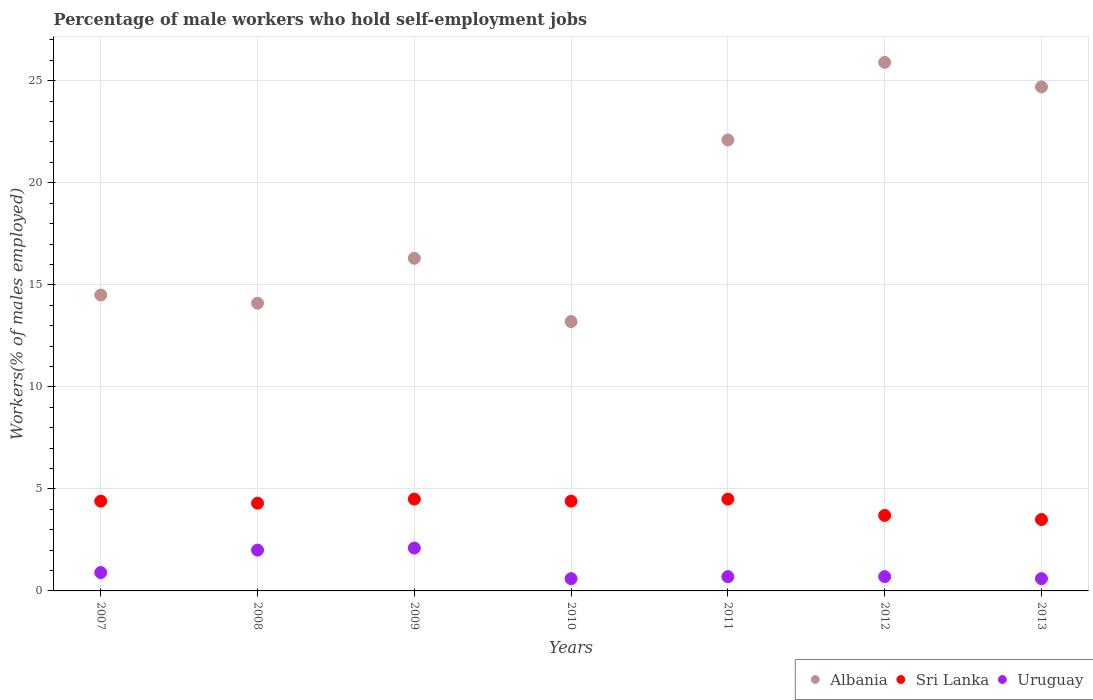How many different coloured dotlines are there?
Make the answer very short. 3. Is the number of dotlines equal to the number of legend labels?
Offer a very short reply. Yes. Across all years, what is the maximum percentage of self-employed male workers in Albania?
Your answer should be very brief. 25.9. Across all years, what is the minimum percentage of self-employed male workers in Sri Lanka?
Provide a succinct answer. 3.5. In which year was the percentage of self-employed male workers in Uruguay maximum?
Make the answer very short. 2009. In which year was the percentage of self-employed male workers in Uruguay minimum?
Your response must be concise. 2010. What is the total percentage of self-employed male workers in Sri Lanka in the graph?
Your answer should be compact. 29.3. What is the difference between the percentage of self-employed male workers in Albania in 2008 and that in 2010?
Your response must be concise. 0.9. What is the difference between the percentage of self-employed male workers in Albania in 2007 and the percentage of self-employed male workers in Sri Lanka in 2012?
Keep it short and to the point. 10.8. What is the average percentage of self-employed male workers in Sri Lanka per year?
Offer a terse response. 4.19. In the year 2010, what is the difference between the percentage of self-employed male workers in Sri Lanka and percentage of self-employed male workers in Uruguay?
Give a very brief answer. 3.8. What is the ratio of the percentage of self-employed male workers in Albania in 2011 to that in 2013?
Offer a very short reply. 0.89. Is the percentage of self-employed male workers in Sri Lanka in 2011 less than that in 2013?
Make the answer very short. No. Is the difference between the percentage of self-employed male workers in Sri Lanka in 2008 and 2012 greater than the difference between the percentage of self-employed male workers in Uruguay in 2008 and 2012?
Ensure brevity in your answer.  No. What is the difference between the highest and the lowest percentage of self-employed male workers in Sri Lanka?
Offer a terse response. 1. In how many years, is the percentage of self-employed male workers in Albania greater than the average percentage of self-employed male workers in Albania taken over all years?
Give a very brief answer. 3. Is the sum of the percentage of self-employed male workers in Albania in 2007 and 2012 greater than the maximum percentage of self-employed male workers in Sri Lanka across all years?
Give a very brief answer. Yes. How many dotlines are there?
Ensure brevity in your answer.  3. How many years are there in the graph?
Your answer should be compact. 7. What is the difference between two consecutive major ticks on the Y-axis?
Provide a short and direct response. 5. Does the graph contain grids?
Make the answer very short. Yes. Where does the legend appear in the graph?
Provide a succinct answer. Bottom right. How are the legend labels stacked?
Your response must be concise. Horizontal. What is the title of the graph?
Your response must be concise. Percentage of male workers who hold self-employment jobs. What is the label or title of the X-axis?
Your response must be concise. Years. What is the label or title of the Y-axis?
Your answer should be very brief. Workers(% of males employed). What is the Workers(% of males employed) in Albania in 2007?
Your answer should be very brief. 14.5. What is the Workers(% of males employed) of Sri Lanka in 2007?
Your response must be concise. 4.4. What is the Workers(% of males employed) of Uruguay in 2007?
Provide a succinct answer. 0.9. What is the Workers(% of males employed) in Albania in 2008?
Provide a succinct answer. 14.1. What is the Workers(% of males employed) in Sri Lanka in 2008?
Give a very brief answer. 4.3. What is the Workers(% of males employed) in Albania in 2009?
Your answer should be compact. 16.3. What is the Workers(% of males employed) in Uruguay in 2009?
Your answer should be very brief. 2.1. What is the Workers(% of males employed) of Albania in 2010?
Make the answer very short. 13.2. What is the Workers(% of males employed) in Sri Lanka in 2010?
Offer a terse response. 4.4. What is the Workers(% of males employed) of Uruguay in 2010?
Keep it short and to the point. 0.6. What is the Workers(% of males employed) in Albania in 2011?
Give a very brief answer. 22.1. What is the Workers(% of males employed) in Sri Lanka in 2011?
Your response must be concise. 4.5. What is the Workers(% of males employed) of Uruguay in 2011?
Keep it short and to the point. 0.7. What is the Workers(% of males employed) of Albania in 2012?
Offer a terse response. 25.9. What is the Workers(% of males employed) in Sri Lanka in 2012?
Give a very brief answer. 3.7. What is the Workers(% of males employed) in Uruguay in 2012?
Provide a short and direct response. 0.7. What is the Workers(% of males employed) in Albania in 2013?
Provide a succinct answer. 24.7. What is the Workers(% of males employed) in Uruguay in 2013?
Keep it short and to the point. 0.6. Across all years, what is the maximum Workers(% of males employed) of Albania?
Provide a succinct answer. 25.9. Across all years, what is the maximum Workers(% of males employed) of Uruguay?
Provide a succinct answer. 2.1. Across all years, what is the minimum Workers(% of males employed) in Albania?
Ensure brevity in your answer.  13.2. Across all years, what is the minimum Workers(% of males employed) in Sri Lanka?
Your answer should be very brief. 3.5. Across all years, what is the minimum Workers(% of males employed) in Uruguay?
Your answer should be very brief. 0.6. What is the total Workers(% of males employed) in Albania in the graph?
Provide a short and direct response. 130.8. What is the total Workers(% of males employed) of Sri Lanka in the graph?
Offer a very short reply. 29.3. What is the total Workers(% of males employed) of Uruguay in the graph?
Your answer should be very brief. 7.6. What is the difference between the Workers(% of males employed) of Albania in 2007 and that in 2008?
Give a very brief answer. 0.4. What is the difference between the Workers(% of males employed) of Uruguay in 2007 and that in 2008?
Ensure brevity in your answer.  -1.1. What is the difference between the Workers(% of males employed) of Sri Lanka in 2007 and that in 2009?
Give a very brief answer. -0.1. What is the difference between the Workers(% of males employed) of Uruguay in 2007 and that in 2009?
Provide a short and direct response. -1.2. What is the difference between the Workers(% of males employed) in Sri Lanka in 2007 and that in 2010?
Your answer should be very brief. 0. What is the difference between the Workers(% of males employed) in Sri Lanka in 2007 and that in 2011?
Give a very brief answer. -0.1. What is the difference between the Workers(% of males employed) in Albania in 2007 and that in 2012?
Provide a succinct answer. -11.4. What is the difference between the Workers(% of males employed) of Sri Lanka in 2007 and that in 2012?
Make the answer very short. 0.7. What is the difference between the Workers(% of males employed) in Albania in 2007 and that in 2013?
Your response must be concise. -10.2. What is the difference between the Workers(% of males employed) in Sri Lanka in 2007 and that in 2013?
Keep it short and to the point. 0.9. What is the difference between the Workers(% of males employed) in Sri Lanka in 2008 and that in 2009?
Provide a short and direct response. -0.2. What is the difference between the Workers(% of males employed) of Albania in 2008 and that in 2010?
Your response must be concise. 0.9. What is the difference between the Workers(% of males employed) of Sri Lanka in 2008 and that in 2010?
Ensure brevity in your answer.  -0.1. What is the difference between the Workers(% of males employed) of Sri Lanka in 2008 and that in 2011?
Provide a short and direct response. -0.2. What is the difference between the Workers(% of males employed) in Sri Lanka in 2008 and that in 2012?
Make the answer very short. 0.6. What is the difference between the Workers(% of males employed) of Uruguay in 2008 and that in 2012?
Your response must be concise. 1.3. What is the difference between the Workers(% of males employed) in Uruguay in 2008 and that in 2013?
Your answer should be compact. 1.4. What is the difference between the Workers(% of males employed) in Sri Lanka in 2009 and that in 2010?
Offer a very short reply. 0.1. What is the difference between the Workers(% of males employed) of Uruguay in 2009 and that in 2010?
Ensure brevity in your answer.  1.5. What is the difference between the Workers(% of males employed) of Uruguay in 2009 and that in 2011?
Provide a short and direct response. 1.4. What is the difference between the Workers(% of males employed) in Albania in 2009 and that in 2012?
Ensure brevity in your answer.  -9.6. What is the difference between the Workers(% of males employed) of Albania in 2009 and that in 2013?
Give a very brief answer. -8.4. What is the difference between the Workers(% of males employed) in Albania in 2010 and that in 2011?
Your response must be concise. -8.9. What is the difference between the Workers(% of males employed) in Sri Lanka in 2010 and that in 2011?
Offer a very short reply. -0.1. What is the difference between the Workers(% of males employed) in Uruguay in 2010 and that in 2011?
Ensure brevity in your answer.  -0.1. What is the difference between the Workers(% of males employed) of Sri Lanka in 2010 and that in 2012?
Provide a short and direct response. 0.7. What is the difference between the Workers(% of males employed) of Uruguay in 2010 and that in 2012?
Your answer should be compact. -0.1. What is the difference between the Workers(% of males employed) in Albania in 2011 and that in 2012?
Give a very brief answer. -3.8. What is the difference between the Workers(% of males employed) of Albania in 2011 and that in 2013?
Your response must be concise. -2.6. What is the difference between the Workers(% of males employed) in Albania in 2012 and that in 2013?
Offer a terse response. 1.2. What is the difference between the Workers(% of males employed) of Uruguay in 2012 and that in 2013?
Make the answer very short. 0.1. What is the difference between the Workers(% of males employed) in Albania in 2007 and the Workers(% of males employed) in Sri Lanka in 2008?
Your answer should be very brief. 10.2. What is the difference between the Workers(% of males employed) of Albania in 2007 and the Workers(% of males employed) of Uruguay in 2008?
Ensure brevity in your answer.  12.5. What is the difference between the Workers(% of males employed) of Albania in 2007 and the Workers(% of males employed) of Sri Lanka in 2009?
Ensure brevity in your answer.  10. What is the difference between the Workers(% of males employed) in Albania in 2007 and the Workers(% of males employed) in Uruguay in 2009?
Your response must be concise. 12.4. What is the difference between the Workers(% of males employed) of Albania in 2007 and the Workers(% of males employed) of Sri Lanka in 2010?
Ensure brevity in your answer.  10.1. What is the difference between the Workers(% of males employed) in Sri Lanka in 2007 and the Workers(% of males employed) in Uruguay in 2011?
Keep it short and to the point. 3.7. What is the difference between the Workers(% of males employed) in Sri Lanka in 2007 and the Workers(% of males employed) in Uruguay in 2012?
Your answer should be compact. 3.7. What is the difference between the Workers(% of males employed) of Albania in 2007 and the Workers(% of males employed) of Sri Lanka in 2013?
Provide a short and direct response. 11. What is the difference between the Workers(% of males employed) of Sri Lanka in 2007 and the Workers(% of males employed) of Uruguay in 2013?
Your answer should be very brief. 3.8. What is the difference between the Workers(% of males employed) of Albania in 2008 and the Workers(% of males employed) of Sri Lanka in 2010?
Give a very brief answer. 9.7. What is the difference between the Workers(% of males employed) in Albania in 2008 and the Workers(% of males employed) in Uruguay in 2011?
Your response must be concise. 13.4. What is the difference between the Workers(% of males employed) of Albania in 2008 and the Workers(% of males employed) of Sri Lanka in 2012?
Your answer should be compact. 10.4. What is the difference between the Workers(% of males employed) of Sri Lanka in 2008 and the Workers(% of males employed) of Uruguay in 2012?
Give a very brief answer. 3.6. What is the difference between the Workers(% of males employed) of Sri Lanka in 2009 and the Workers(% of males employed) of Uruguay in 2010?
Your answer should be very brief. 3.9. What is the difference between the Workers(% of males employed) in Albania in 2009 and the Workers(% of males employed) in Uruguay in 2011?
Provide a succinct answer. 15.6. What is the difference between the Workers(% of males employed) in Sri Lanka in 2009 and the Workers(% of males employed) in Uruguay in 2011?
Keep it short and to the point. 3.8. What is the difference between the Workers(% of males employed) of Albania in 2009 and the Workers(% of males employed) of Sri Lanka in 2012?
Give a very brief answer. 12.6. What is the difference between the Workers(% of males employed) in Albania in 2009 and the Workers(% of males employed) in Uruguay in 2012?
Keep it short and to the point. 15.6. What is the difference between the Workers(% of males employed) in Albania in 2009 and the Workers(% of males employed) in Sri Lanka in 2013?
Ensure brevity in your answer.  12.8. What is the difference between the Workers(% of males employed) in Albania in 2009 and the Workers(% of males employed) in Uruguay in 2013?
Ensure brevity in your answer.  15.7. What is the difference between the Workers(% of males employed) in Sri Lanka in 2010 and the Workers(% of males employed) in Uruguay in 2011?
Provide a succinct answer. 3.7. What is the difference between the Workers(% of males employed) in Albania in 2010 and the Workers(% of males employed) in Uruguay in 2012?
Your response must be concise. 12.5. What is the difference between the Workers(% of males employed) in Sri Lanka in 2010 and the Workers(% of males employed) in Uruguay in 2013?
Keep it short and to the point. 3.8. What is the difference between the Workers(% of males employed) in Albania in 2011 and the Workers(% of males employed) in Sri Lanka in 2012?
Offer a very short reply. 18.4. What is the difference between the Workers(% of males employed) of Albania in 2011 and the Workers(% of males employed) of Uruguay in 2012?
Offer a terse response. 21.4. What is the difference between the Workers(% of males employed) of Albania in 2012 and the Workers(% of males employed) of Sri Lanka in 2013?
Your answer should be compact. 22.4. What is the difference between the Workers(% of males employed) in Albania in 2012 and the Workers(% of males employed) in Uruguay in 2013?
Offer a terse response. 25.3. What is the average Workers(% of males employed) in Albania per year?
Your answer should be very brief. 18.69. What is the average Workers(% of males employed) in Sri Lanka per year?
Offer a very short reply. 4.19. What is the average Workers(% of males employed) in Uruguay per year?
Offer a very short reply. 1.09. In the year 2007, what is the difference between the Workers(% of males employed) in Albania and Workers(% of males employed) in Uruguay?
Keep it short and to the point. 13.6. In the year 2007, what is the difference between the Workers(% of males employed) in Sri Lanka and Workers(% of males employed) in Uruguay?
Give a very brief answer. 3.5. In the year 2010, what is the difference between the Workers(% of males employed) of Sri Lanka and Workers(% of males employed) of Uruguay?
Make the answer very short. 3.8. In the year 2011, what is the difference between the Workers(% of males employed) of Albania and Workers(% of males employed) of Sri Lanka?
Offer a terse response. 17.6. In the year 2011, what is the difference between the Workers(% of males employed) in Albania and Workers(% of males employed) in Uruguay?
Ensure brevity in your answer.  21.4. In the year 2012, what is the difference between the Workers(% of males employed) in Albania and Workers(% of males employed) in Uruguay?
Your answer should be compact. 25.2. In the year 2012, what is the difference between the Workers(% of males employed) in Sri Lanka and Workers(% of males employed) in Uruguay?
Your answer should be very brief. 3. In the year 2013, what is the difference between the Workers(% of males employed) of Albania and Workers(% of males employed) of Sri Lanka?
Ensure brevity in your answer.  21.2. In the year 2013, what is the difference between the Workers(% of males employed) of Albania and Workers(% of males employed) of Uruguay?
Ensure brevity in your answer.  24.1. What is the ratio of the Workers(% of males employed) of Albania in 2007 to that in 2008?
Keep it short and to the point. 1.03. What is the ratio of the Workers(% of males employed) of Sri Lanka in 2007 to that in 2008?
Provide a short and direct response. 1.02. What is the ratio of the Workers(% of males employed) in Uruguay in 2007 to that in 2008?
Ensure brevity in your answer.  0.45. What is the ratio of the Workers(% of males employed) in Albania in 2007 to that in 2009?
Give a very brief answer. 0.89. What is the ratio of the Workers(% of males employed) in Sri Lanka in 2007 to that in 2009?
Keep it short and to the point. 0.98. What is the ratio of the Workers(% of males employed) in Uruguay in 2007 to that in 2009?
Provide a short and direct response. 0.43. What is the ratio of the Workers(% of males employed) of Albania in 2007 to that in 2010?
Your response must be concise. 1.1. What is the ratio of the Workers(% of males employed) of Albania in 2007 to that in 2011?
Provide a short and direct response. 0.66. What is the ratio of the Workers(% of males employed) of Sri Lanka in 2007 to that in 2011?
Make the answer very short. 0.98. What is the ratio of the Workers(% of males employed) of Uruguay in 2007 to that in 2011?
Offer a terse response. 1.29. What is the ratio of the Workers(% of males employed) of Albania in 2007 to that in 2012?
Keep it short and to the point. 0.56. What is the ratio of the Workers(% of males employed) of Sri Lanka in 2007 to that in 2012?
Make the answer very short. 1.19. What is the ratio of the Workers(% of males employed) of Uruguay in 2007 to that in 2012?
Offer a very short reply. 1.29. What is the ratio of the Workers(% of males employed) in Albania in 2007 to that in 2013?
Your answer should be compact. 0.59. What is the ratio of the Workers(% of males employed) of Sri Lanka in 2007 to that in 2013?
Offer a terse response. 1.26. What is the ratio of the Workers(% of males employed) in Uruguay in 2007 to that in 2013?
Your answer should be compact. 1.5. What is the ratio of the Workers(% of males employed) of Albania in 2008 to that in 2009?
Offer a terse response. 0.86. What is the ratio of the Workers(% of males employed) in Sri Lanka in 2008 to that in 2009?
Provide a succinct answer. 0.96. What is the ratio of the Workers(% of males employed) of Albania in 2008 to that in 2010?
Provide a short and direct response. 1.07. What is the ratio of the Workers(% of males employed) of Sri Lanka in 2008 to that in 2010?
Keep it short and to the point. 0.98. What is the ratio of the Workers(% of males employed) in Uruguay in 2008 to that in 2010?
Provide a succinct answer. 3.33. What is the ratio of the Workers(% of males employed) in Albania in 2008 to that in 2011?
Offer a very short reply. 0.64. What is the ratio of the Workers(% of males employed) of Sri Lanka in 2008 to that in 2011?
Your answer should be very brief. 0.96. What is the ratio of the Workers(% of males employed) in Uruguay in 2008 to that in 2011?
Provide a short and direct response. 2.86. What is the ratio of the Workers(% of males employed) in Albania in 2008 to that in 2012?
Your response must be concise. 0.54. What is the ratio of the Workers(% of males employed) of Sri Lanka in 2008 to that in 2012?
Your answer should be compact. 1.16. What is the ratio of the Workers(% of males employed) in Uruguay in 2008 to that in 2012?
Your answer should be compact. 2.86. What is the ratio of the Workers(% of males employed) in Albania in 2008 to that in 2013?
Offer a very short reply. 0.57. What is the ratio of the Workers(% of males employed) of Sri Lanka in 2008 to that in 2013?
Your response must be concise. 1.23. What is the ratio of the Workers(% of males employed) of Albania in 2009 to that in 2010?
Your answer should be very brief. 1.23. What is the ratio of the Workers(% of males employed) of Sri Lanka in 2009 to that in 2010?
Provide a short and direct response. 1.02. What is the ratio of the Workers(% of males employed) of Albania in 2009 to that in 2011?
Provide a succinct answer. 0.74. What is the ratio of the Workers(% of males employed) of Sri Lanka in 2009 to that in 2011?
Make the answer very short. 1. What is the ratio of the Workers(% of males employed) in Uruguay in 2009 to that in 2011?
Provide a short and direct response. 3. What is the ratio of the Workers(% of males employed) of Albania in 2009 to that in 2012?
Provide a short and direct response. 0.63. What is the ratio of the Workers(% of males employed) in Sri Lanka in 2009 to that in 2012?
Provide a succinct answer. 1.22. What is the ratio of the Workers(% of males employed) of Albania in 2009 to that in 2013?
Make the answer very short. 0.66. What is the ratio of the Workers(% of males employed) in Sri Lanka in 2009 to that in 2013?
Ensure brevity in your answer.  1.29. What is the ratio of the Workers(% of males employed) in Uruguay in 2009 to that in 2013?
Offer a very short reply. 3.5. What is the ratio of the Workers(% of males employed) of Albania in 2010 to that in 2011?
Give a very brief answer. 0.6. What is the ratio of the Workers(% of males employed) in Sri Lanka in 2010 to that in 2011?
Make the answer very short. 0.98. What is the ratio of the Workers(% of males employed) in Albania in 2010 to that in 2012?
Ensure brevity in your answer.  0.51. What is the ratio of the Workers(% of males employed) of Sri Lanka in 2010 to that in 2012?
Your response must be concise. 1.19. What is the ratio of the Workers(% of males employed) in Albania in 2010 to that in 2013?
Your answer should be compact. 0.53. What is the ratio of the Workers(% of males employed) of Sri Lanka in 2010 to that in 2013?
Offer a terse response. 1.26. What is the ratio of the Workers(% of males employed) of Uruguay in 2010 to that in 2013?
Your answer should be very brief. 1. What is the ratio of the Workers(% of males employed) of Albania in 2011 to that in 2012?
Your answer should be very brief. 0.85. What is the ratio of the Workers(% of males employed) in Sri Lanka in 2011 to that in 2012?
Ensure brevity in your answer.  1.22. What is the ratio of the Workers(% of males employed) in Albania in 2011 to that in 2013?
Give a very brief answer. 0.89. What is the ratio of the Workers(% of males employed) in Sri Lanka in 2011 to that in 2013?
Your answer should be compact. 1.29. What is the ratio of the Workers(% of males employed) of Uruguay in 2011 to that in 2013?
Your answer should be very brief. 1.17. What is the ratio of the Workers(% of males employed) in Albania in 2012 to that in 2013?
Provide a succinct answer. 1.05. What is the ratio of the Workers(% of males employed) in Sri Lanka in 2012 to that in 2013?
Your response must be concise. 1.06. What is the ratio of the Workers(% of males employed) of Uruguay in 2012 to that in 2013?
Your response must be concise. 1.17. 